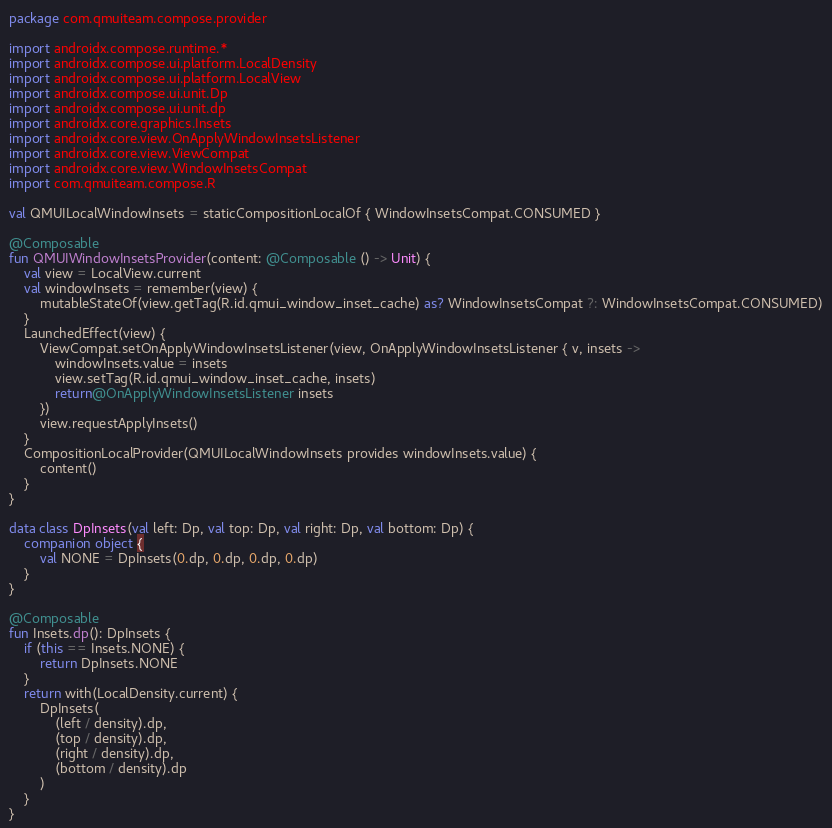Convert code to text. <code><loc_0><loc_0><loc_500><loc_500><_Kotlin_>package com.qmuiteam.compose.provider

import androidx.compose.runtime.*
import androidx.compose.ui.platform.LocalDensity
import androidx.compose.ui.platform.LocalView
import androidx.compose.ui.unit.Dp
import androidx.compose.ui.unit.dp
import androidx.core.graphics.Insets
import androidx.core.view.OnApplyWindowInsetsListener
import androidx.core.view.ViewCompat
import androidx.core.view.WindowInsetsCompat
import com.qmuiteam.compose.R

val QMUILocalWindowInsets = staticCompositionLocalOf { WindowInsetsCompat.CONSUMED }

@Composable
fun QMUIWindowInsetsProvider(content: @Composable () -> Unit) {
    val view = LocalView.current
    val windowInsets = remember(view) {
        mutableStateOf(view.getTag(R.id.qmui_window_inset_cache) as? WindowInsetsCompat ?: WindowInsetsCompat.CONSUMED)
    }
    LaunchedEffect(view) {
        ViewCompat.setOnApplyWindowInsetsListener(view, OnApplyWindowInsetsListener { v, insets ->
            windowInsets.value = insets
            view.setTag(R.id.qmui_window_inset_cache, insets)
            return@OnApplyWindowInsetsListener insets
        })
        view.requestApplyInsets()
    }
    CompositionLocalProvider(QMUILocalWindowInsets provides windowInsets.value) {
        content()
    }
}

data class DpInsets(val left: Dp, val top: Dp, val right: Dp, val bottom: Dp) {
    companion object {
        val NONE = DpInsets(0.dp, 0.dp, 0.dp, 0.dp)
    }
}

@Composable
fun Insets.dp(): DpInsets {
    if (this == Insets.NONE) {
        return DpInsets.NONE
    }
    return with(LocalDensity.current) {
        DpInsets(
            (left / density).dp,
            (top / density).dp,
            (right / density).dp,
            (bottom / density).dp
        )
    }
}</code> 